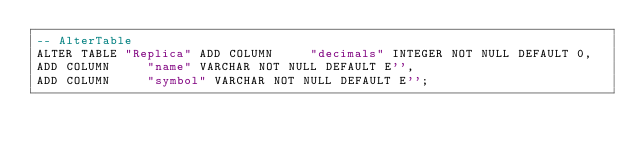Convert code to text. <code><loc_0><loc_0><loc_500><loc_500><_SQL_>-- AlterTable
ALTER TABLE "Replica" ADD COLUMN     "decimals" INTEGER NOT NULL DEFAULT 0,
ADD COLUMN     "name" VARCHAR NOT NULL DEFAULT E'',
ADD COLUMN     "symbol" VARCHAR NOT NULL DEFAULT E'';
</code> 